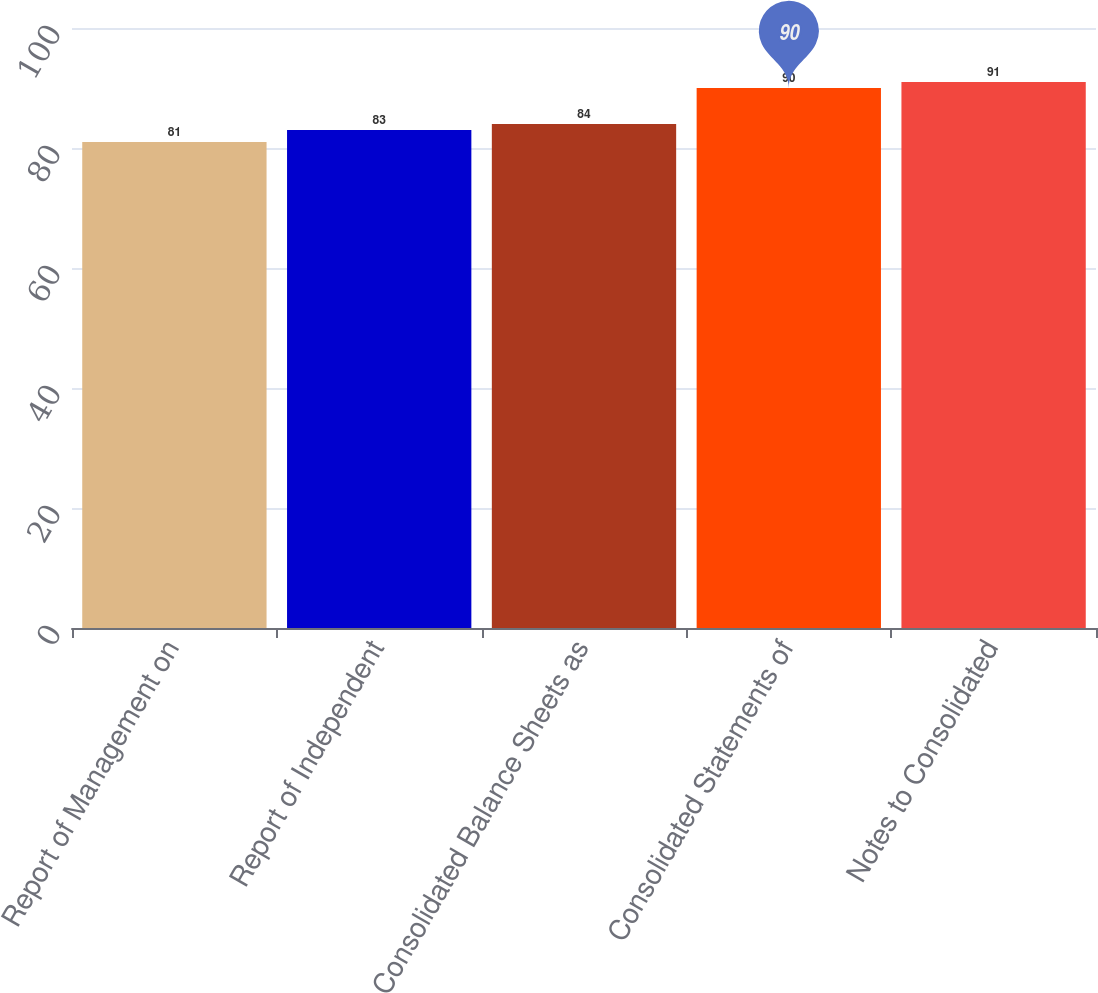Convert chart. <chart><loc_0><loc_0><loc_500><loc_500><bar_chart><fcel>Report of Management on<fcel>Report of Independent<fcel>Consolidated Balance Sheets as<fcel>Consolidated Statements of<fcel>Notes to Consolidated<nl><fcel>81<fcel>83<fcel>84<fcel>90<fcel>91<nl></chart> 